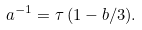<formula> <loc_0><loc_0><loc_500><loc_500>a ^ { - 1 } = \tau \, ( 1 - b / 3 ) .</formula> 